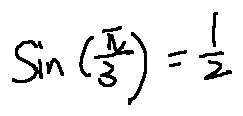<formula> <loc_0><loc_0><loc_500><loc_500>\sin ( \frac { \pi } { 3 } ) = \frac { 1 } { 2 }</formula> 